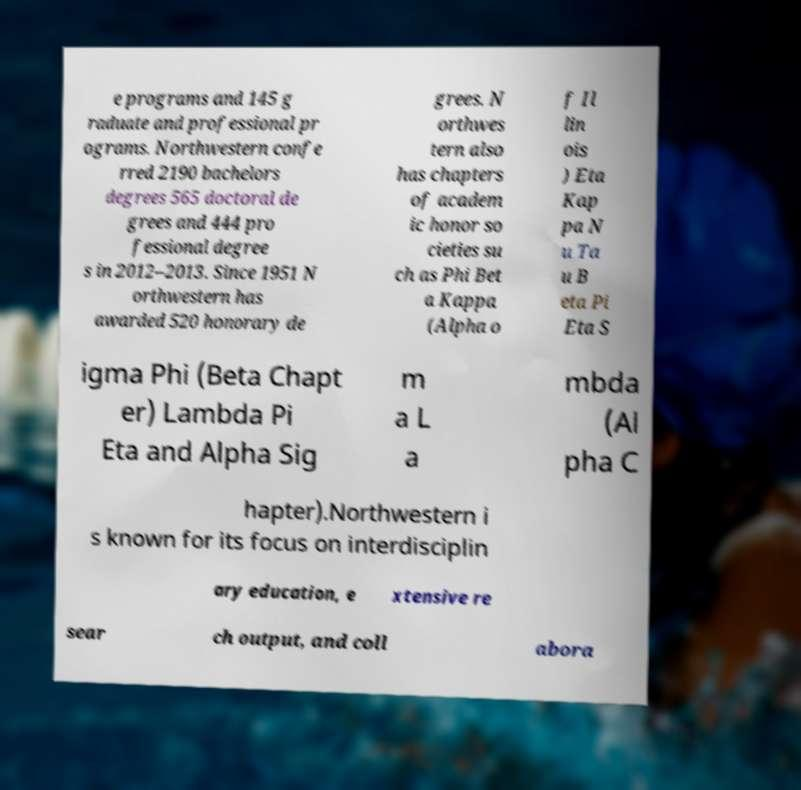For documentation purposes, I need the text within this image transcribed. Could you provide that? e programs and 145 g raduate and professional pr ograms. Northwestern confe rred 2190 bachelors degrees 565 doctoral de grees and 444 pro fessional degree s in 2012–2013. Since 1951 N orthwestern has awarded 520 honorary de grees. N orthwes tern also has chapters of academ ic honor so cieties su ch as Phi Bet a Kappa (Alpha o f Il lin ois ) Eta Kap pa N u Ta u B eta Pi Eta S igma Phi (Beta Chapt er) Lambda Pi Eta and Alpha Sig m a L a mbda (Al pha C hapter).Northwestern i s known for its focus on interdisciplin ary education, e xtensive re sear ch output, and coll abora 